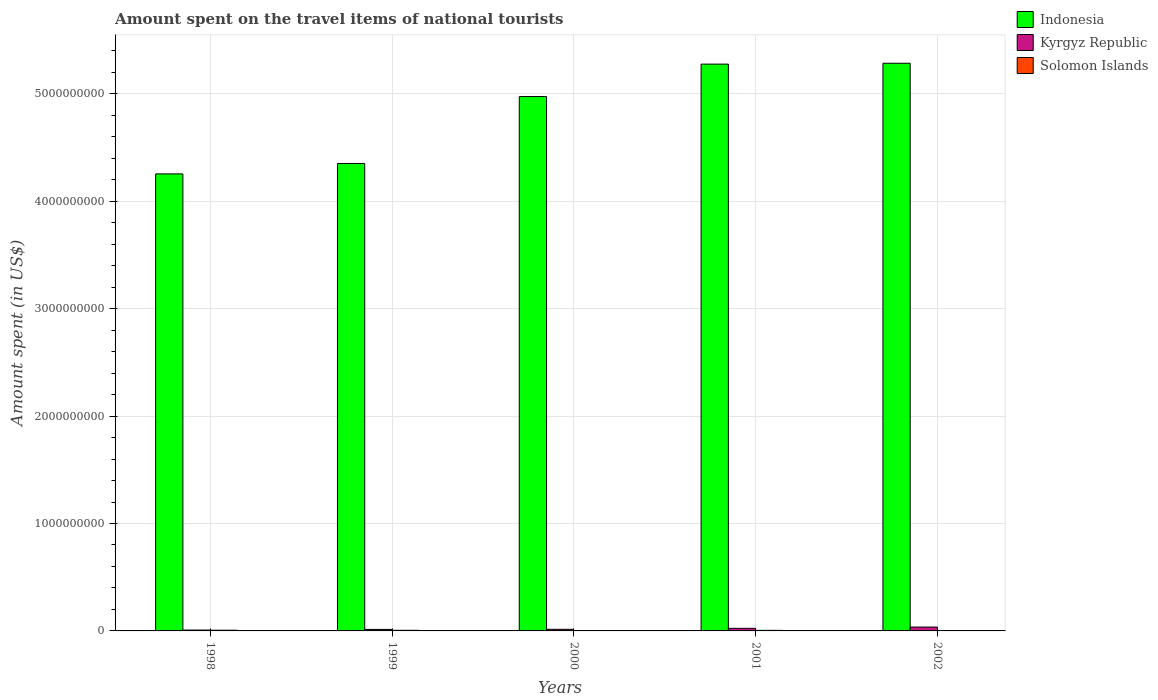How many groups of bars are there?
Your response must be concise. 5. Are the number of bars on each tick of the X-axis equal?
Ensure brevity in your answer.  Yes. How many bars are there on the 4th tick from the left?
Provide a succinct answer. 3. What is the label of the 1st group of bars from the left?
Your response must be concise. 1998. What is the amount spent on the travel items of national tourists in Solomon Islands in 2002?
Give a very brief answer. 7.00e+05. Across all years, what is the maximum amount spent on the travel items of national tourists in Indonesia?
Your answer should be very brief. 5.28e+09. Across all years, what is the minimum amount spent on the travel items of national tourists in Solomon Islands?
Give a very brief answer. 7.00e+05. In which year was the amount spent on the travel items of national tourists in Indonesia minimum?
Give a very brief answer. 1998. What is the total amount spent on the travel items of national tourists in Solomon Islands in the graph?
Offer a very short reply. 2.21e+07. What is the difference between the amount spent on the travel items of national tourists in Solomon Islands in 1999 and that in 2000?
Offer a very short reply. 1.80e+06. What is the difference between the amount spent on the travel items of national tourists in Kyrgyz Republic in 2000 and the amount spent on the travel items of national tourists in Indonesia in 1999?
Provide a succinct answer. -4.34e+09. What is the average amount spent on the travel items of national tourists in Solomon Islands per year?
Provide a succinct answer. 4.42e+06. In the year 2001, what is the difference between the amount spent on the travel items of national tourists in Indonesia and amount spent on the travel items of national tourists in Solomon Islands?
Give a very brief answer. 5.27e+09. What is the ratio of the amount spent on the travel items of national tourists in Solomon Islands in 1998 to that in 1999?
Make the answer very short. 1.16. Is the difference between the amount spent on the travel items of national tourists in Indonesia in 1998 and 1999 greater than the difference between the amount spent on the travel items of national tourists in Solomon Islands in 1998 and 1999?
Give a very brief answer. No. What is the difference between the highest and the lowest amount spent on the travel items of national tourists in Kyrgyz Republic?
Make the answer very short. 2.80e+07. In how many years, is the amount spent on the travel items of national tourists in Kyrgyz Republic greater than the average amount spent on the travel items of national tourists in Kyrgyz Republic taken over all years?
Your answer should be compact. 2. What does the 2nd bar from the left in 2000 represents?
Ensure brevity in your answer.  Kyrgyz Republic. What does the 2nd bar from the right in 2000 represents?
Make the answer very short. Kyrgyz Republic. Is it the case that in every year, the sum of the amount spent on the travel items of national tourists in Indonesia and amount spent on the travel items of national tourists in Solomon Islands is greater than the amount spent on the travel items of national tourists in Kyrgyz Republic?
Provide a succinct answer. Yes. How many bars are there?
Your response must be concise. 15. How many years are there in the graph?
Offer a very short reply. 5. Are the values on the major ticks of Y-axis written in scientific E-notation?
Your answer should be compact. No. Where does the legend appear in the graph?
Ensure brevity in your answer.  Top right. How are the legend labels stacked?
Provide a succinct answer. Vertical. What is the title of the graph?
Provide a short and direct response. Amount spent on the travel items of national tourists. What is the label or title of the Y-axis?
Your answer should be compact. Amount spent (in US$). What is the Amount spent (in US$) in Indonesia in 1998?
Give a very brief answer. 4.26e+09. What is the Amount spent (in US$) of Kyrgyz Republic in 1998?
Make the answer very short. 8.00e+06. What is the Amount spent (in US$) of Solomon Islands in 1998?
Keep it short and to the point. 6.60e+06. What is the Amount spent (in US$) of Indonesia in 1999?
Ensure brevity in your answer.  4.35e+09. What is the Amount spent (in US$) in Kyrgyz Republic in 1999?
Your answer should be compact. 1.40e+07. What is the Amount spent (in US$) in Solomon Islands in 1999?
Keep it short and to the point. 5.70e+06. What is the Amount spent (in US$) in Indonesia in 2000?
Provide a succinct answer. 4.98e+09. What is the Amount spent (in US$) in Kyrgyz Republic in 2000?
Offer a very short reply. 1.50e+07. What is the Amount spent (in US$) of Solomon Islands in 2000?
Offer a very short reply. 3.90e+06. What is the Amount spent (in US$) in Indonesia in 2001?
Ensure brevity in your answer.  5.28e+09. What is the Amount spent (in US$) in Kyrgyz Republic in 2001?
Offer a terse response. 2.40e+07. What is the Amount spent (in US$) of Solomon Islands in 2001?
Your answer should be very brief. 5.20e+06. What is the Amount spent (in US$) in Indonesia in 2002?
Offer a terse response. 5.28e+09. What is the Amount spent (in US$) in Kyrgyz Republic in 2002?
Give a very brief answer. 3.60e+07. What is the Amount spent (in US$) in Solomon Islands in 2002?
Offer a terse response. 7.00e+05. Across all years, what is the maximum Amount spent (in US$) in Indonesia?
Ensure brevity in your answer.  5.28e+09. Across all years, what is the maximum Amount spent (in US$) of Kyrgyz Republic?
Offer a very short reply. 3.60e+07. Across all years, what is the maximum Amount spent (in US$) in Solomon Islands?
Keep it short and to the point. 6.60e+06. Across all years, what is the minimum Amount spent (in US$) of Indonesia?
Give a very brief answer. 4.26e+09. Across all years, what is the minimum Amount spent (in US$) of Kyrgyz Republic?
Keep it short and to the point. 8.00e+06. Across all years, what is the minimum Amount spent (in US$) of Solomon Islands?
Provide a short and direct response. 7.00e+05. What is the total Amount spent (in US$) in Indonesia in the graph?
Ensure brevity in your answer.  2.41e+1. What is the total Amount spent (in US$) in Kyrgyz Republic in the graph?
Your response must be concise. 9.70e+07. What is the total Amount spent (in US$) in Solomon Islands in the graph?
Provide a short and direct response. 2.21e+07. What is the difference between the Amount spent (in US$) of Indonesia in 1998 and that in 1999?
Offer a terse response. -9.70e+07. What is the difference between the Amount spent (in US$) of Kyrgyz Republic in 1998 and that in 1999?
Ensure brevity in your answer.  -6.00e+06. What is the difference between the Amount spent (in US$) in Solomon Islands in 1998 and that in 1999?
Make the answer very short. 9.00e+05. What is the difference between the Amount spent (in US$) in Indonesia in 1998 and that in 2000?
Provide a short and direct response. -7.20e+08. What is the difference between the Amount spent (in US$) in Kyrgyz Republic in 1998 and that in 2000?
Ensure brevity in your answer.  -7.00e+06. What is the difference between the Amount spent (in US$) of Solomon Islands in 1998 and that in 2000?
Your answer should be compact. 2.70e+06. What is the difference between the Amount spent (in US$) of Indonesia in 1998 and that in 2001?
Make the answer very short. -1.02e+09. What is the difference between the Amount spent (in US$) of Kyrgyz Republic in 1998 and that in 2001?
Keep it short and to the point. -1.60e+07. What is the difference between the Amount spent (in US$) in Solomon Islands in 1998 and that in 2001?
Offer a very short reply. 1.40e+06. What is the difference between the Amount spent (in US$) of Indonesia in 1998 and that in 2002?
Provide a short and direct response. -1.03e+09. What is the difference between the Amount spent (in US$) of Kyrgyz Republic in 1998 and that in 2002?
Your answer should be very brief. -2.80e+07. What is the difference between the Amount spent (in US$) in Solomon Islands in 1998 and that in 2002?
Ensure brevity in your answer.  5.90e+06. What is the difference between the Amount spent (in US$) of Indonesia in 1999 and that in 2000?
Offer a terse response. -6.23e+08. What is the difference between the Amount spent (in US$) of Kyrgyz Republic in 1999 and that in 2000?
Ensure brevity in your answer.  -1.00e+06. What is the difference between the Amount spent (in US$) in Solomon Islands in 1999 and that in 2000?
Offer a terse response. 1.80e+06. What is the difference between the Amount spent (in US$) of Indonesia in 1999 and that in 2001?
Offer a very short reply. -9.25e+08. What is the difference between the Amount spent (in US$) in Kyrgyz Republic in 1999 and that in 2001?
Ensure brevity in your answer.  -1.00e+07. What is the difference between the Amount spent (in US$) of Solomon Islands in 1999 and that in 2001?
Your answer should be compact. 5.00e+05. What is the difference between the Amount spent (in US$) of Indonesia in 1999 and that in 2002?
Provide a short and direct response. -9.33e+08. What is the difference between the Amount spent (in US$) of Kyrgyz Republic in 1999 and that in 2002?
Your response must be concise. -2.20e+07. What is the difference between the Amount spent (in US$) in Solomon Islands in 1999 and that in 2002?
Make the answer very short. 5.00e+06. What is the difference between the Amount spent (in US$) of Indonesia in 2000 and that in 2001?
Give a very brief answer. -3.02e+08. What is the difference between the Amount spent (in US$) of Kyrgyz Republic in 2000 and that in 2001?
Give a very brief answer. -9.00e+06. What is the difference between the Amount spent (in US$) in Solomon Islands in 2000 and that in 2001?
Make the answer very short. -1.30e+06. What is the difference between the Amount spent (in US$) in Indonesia in 2000 and that in 2002?
Provide a succinct answer. -3.10e+08. What is the difference between the Amount spent (in US$) of Kyrgyz Republic in 2000 and that in 2002?
Your answer should be compact. -2.10e+07. What is the difference between the Amount spent (in US$) in Solomon Islands in 2000 and that in 2002?
Your answer should be compact. 3.20e+06. What is the difference between the Amount spent (in US$) of Indonesia in 2001 and that in 2002?
Your answer should be very brief. -8.00e+06. What is the difference between the Amount spent (in US$) in Kyrgyz Republic in 2001 and that in 2002?
Give a very brief answer. -1.20e+07. What is the difference between the Amount spent (in US$) in Solomon Islands in 2001 and that in 2002?
Your answer should be very brief. 4.50e+06. What is the difference between the Amount spent (in US$) of Indonesia in 1998 and the Amount spent (in US$) of Kyrgyz Republic in 1999?
Make the answer very short. 4.24e+09. What is the difference between the Amount spent (in US$) of Indonesia in 1998 and the Amount spent (in US$) of Solomon Islands in 1999?
Provide a succinct answer. 4.25e+09. What is the difference between the Amount spent (in US$) in Kyrgyz Republic in 1998 and the Amount spent (in US$) in Solomon Islands in 1999?
Your response must be concise. 2.30e+06. What is the difference between the Amount spent (in US$) in Indonesia in 1998 and the Amount spent (in US$) in Kyrgyz Republic in 2000?
Provide a short and direct response. 4.24e+09. What is the difference between the Amount spent (in US$) of Indonesia in 1998 and the Amount spent (in US$) of Solomon Islands in 2000?
Make the answer very short. 4.25e+09. What is the difference between the Amount spent (in US$) in Kyrgyz Republic in 1998 and the Amount spent (in US$) in Solomon Islands in 2000?
Keep it short and to the point. 4.10e+06. What is the difference between the Amount spent (in US$) of Indonesia in 1998 and the Amount spent (in US$) of Kyrgyz Republic in 2001?
Provide a short and direct response. 4.23e+09. What is the difference between the Amount spent (in US$) of Indonesia in 1998 and the Amount spent (in US$) of Solomon Islands in 2001?
Provide a short and direct response. 4.25e+09. What is the difference between the Amount spent (in US$) in Kyrgyz Republic in 1998 and the Amount spent (in US$) in Solomon Islands in 2001?
Provide a short and direct response. 2.80e+06. What is the difference between the Amount spent (in US$) in Indonesia in 1998 and the Amount spent (in US$) in Kyrgyz Republic in 2002?
Offer a terse response. 4.22e+09. What is the difference between the Amount spent (in US$) of Indonesia in 1998 and the Amount spent (in US$) of Solomon Islands in 2002?
Provide a short and direct response. 4.25e+09. What is the difference between the Amount spent (in US$) of Kyrgyz Republic in 1998 and the Amount spent (in US$) of Solomon Islands in 2002?
Ensure brevity in your answer.  7.30e+06. What is the difference between the Amount spent (in US$) of Indonesia in 1999 and the Amount spent (in US$) of Kyrgyz Republic in 2000?
Give a very brief answer. 4.34e+09. What is the difference between the Amount spent (in US$) in Indonesia in 1999 and the Amount spent (in US$) in Solomon Islands in 2000?
Offer a very short reply. 4.35e+09. What is the difference between the Amount spent (in US$) of Kyrgyz Republic in 1999 and the Amount spent (in US$) of Solomon Islands in 2000?
Ensure brevity in your answer.  1.01e+07. What is the difference between the Amount spent (in US$) in Indonesia in 1999 and the Amount spent (in US$) in Kyrgyz Republic in 2001?
Provide a succinct answer. 4.33e+09. What is the difference between the Amount spent (in US$) of Indonesia in 1999 and the Amount spent (in US$) of Solomon Islands in 2001?
Ensure brevity in your answer.  4.35e+09. What is the difference between the Amount spent (in US$) in Kyrgyz Republic in 1999 and the Amount spent (in US$) in Solomon Islands in 2001?
Keep it short and to the point. 8.80e+06. What is the difference between the Amount spent (in US$) in Indonesia in 1999 and the Amount spent (in US$) in Kyrgyz Republic in 2002?
Your answer should be very brief. 4.32e+09. What is the difference between the Amount spent (in US$) in Indonesia in 1999 and the Amount spent (in US$) in Solomon Islands in 2002?
Ensure brevity in your answer.  4.35e+09. What is the difference between the Amount spent (in US$) of Kyrgyz Republic in 1999 and the Amount spent (in US$) of Solomon Islands in 2002?
Give a very brief answer. 1.33e+07. What is the difference between the Amount spent (in US$) in Indonesia in 2000 and the Amount spent (in US$) in Kyrgyz Republic in 2001?
Offer a terse response. 4.95e+09. What is the difference between the Amount spent (in US$) of Indonesia in 2000 and the Amount spent (in US$) of Solomon Islands in 2001?
Your answer should be compact. 4.97e+09. What is the difference between the Amount spent (in US$) of Kyrgyz Republic in 2000 and the Amount spent (in US$) of Solomon Islands in 2001?
Your answer should be compact. 9.80e+06. What is the difference between the Amount spent (in US$) of Indonesia in 2000 and the Amount spent (in US$) of Kyrgyz Republic in 2002?
Provide a short and direct response. 4.94e+09. What is the difference between the Amount spent (in US$) of Indonesia in 2000 and the Amount spent (in US$) of Solomon Islands in 2002?
Offer a terse response. 4.97e+09. What is the difference between the Amount spent (in US$) of Kyrgyz Republic in 2000 and the Amount spent (in US$) of Solomon Islands in 2002?
Keep it short and to the point. 1.43e+07. What is the difference between the Amount spent (in US$) of Indonesia in 2001 and the Amount spent (in US$) of Kyrgyz Republic in 2002?
Make the answer very short. 5.24e+09. What is the difference between the Amount spent (in US$) of Indonesia in 2001 and the Amount spent (in US$) of Solomon Islands in 2002?
Make the answer very short. 5.28e+09. What is the difference between the Amount spent (in US$) of Kyrgyz Republic in 2001 and the Amount spent (in US$) of Solomon Islands in 2002?
Your answer should be compact. 2.33e+07. What is the average Amount spent (in US$) of Indonesia per year?
Your answer should be compact. 4.83e+09. What is the average Amount spent (in US$) of Kyrgyz Republic per year?
Make the answer very short. 1.94e+07. What is the average Amount spent (in US$) in Solomon Islands per year?
Provide a short and direct response. 4.42e+06. In the year 1998, what is the difference between the Amount spent (in US$) of Indonesia and Amount spent (in US$) of Kyrgyz Republic?
Keep it short and to the point. 4.25e+09. In the year 1998, what is the difference between the Amount spent (in US$) in Indonesia and Amount spent (in US$) in Solomon Islands?
Your response must be concise. 4.25e+09. In the year 1998, what is the difference between the Amount spent (in US$) in Kyrgyz Republic and Amount spent (in US$) in Solomon Islands?
Your response must be concise. 1.40e+06. In the year 1999, what is the difference between the Amount spent (in US$) of Indonesia and Amount spent (in US$) of Kyrgyz Republic?
Give a very brief answer. 4.34e+09. In the year 1999, what is the difference between the Amount spent (in US$) in Indonesia and Amount spent (in US$) in Solomon Islands?
Your answer should be compact. 4.35e+09. In the year 1999, what is the difference between the Amount spent (in US$) of Kyrgyz Republic and Amount spent (in US$) of Solomon Islands?
Make the answer very short. 8.30e+06. In the year 2000, what is the difference between the Amount spent (in US$) in Indonesia and Amount spent (in US$) in Kyrgyz Republic?
Provide a succinct answer. 4.96e+09. In the year 2000, what is the difference between the Amount spent (in US$) of Indonesia and Amount spent (in US$) of Solomon Islands?
Offer a terse response. 4.97e+09. In the year 2000, what is the difference between the Amount spent (in US$) in Kyrgyz Republic and Amount spent (in US$) in Solomon Islands?
Offer a terse response. 1.11e+07. In the year 2001, what is the difference between the Amount spent (in US$) in Indonesia and Amount spent (in US$) in Kyrgyz Republic?
Your answer should be compact. 5.25e+09. In the year 2001, what is the difference between the Amount spent (in US$) of Indonesia and Amount spent (in US$) of Solomon Islands?
Give a very brief answer. 5.27e+09. In the year 2001, what is the difference between the Amount spent (in US$) of Kyrgyz Republic and Amount spent (in US$) of Solomon Islands?
Your answer should be compact. 1.88e+07. In the year 2002, what is the difference between the Amount spent (in US$) in Indonesia and Amount spent (in US$) in Kyrgyz Republic?
Keep it short and to the point. 5.25e+09. In the year 2002, what is the difference between the Amount spent (in US$) in Indonesia and Amount spent (in US$) in Solomon Islands?
Offer a very short reply. 5.28e+09. In the year 2002, what is the difference between the Amount spent (in US$) of Kyrgyz Republic and Amount spent (in US$) of Solomon Islands?
Offer a very short reply. 3.53e+07. What is the ratio of the Amount spent (in US$) in Indonesia in 1998 to that in 1999?
Ensure brevity in your answer.  0.98. What is the ratio of the Amount spent (in US$) in Solomon Islands in 1998 to that in 1999?
Your answer should be compact. 1.16. What is the ratio of the Amount spent (in US$) of Indonesia in 1998 to that in 2000?
Ensure brevity in your answer.  0.86. What is the ratio of the Amount spent (in US$) in Kyrgyz Republic in 1998 to that in 2000?
Provide a succinct answer. 0.53. What is the ratio of the Amount spent (in US$) of Solomon Islands in 1998 to that in 2000?
Give a very brief answer. 1.69. What is the ratio of the Amount spent (in US$) in Indonesia in 1998 to that in 2001?
Offer a very short reply. 0.81. What is the ratio of the Amount spent (in US$) in Kyrgyz Republic in 1998 to that in 2001?
Your response must be concise. 0.33. What is the ratio of the Amount spent (in US$) in Solomon Islands in 1998 to that in 2001?
Make the answer very short. 1.27. What is the ratio of the Amount spent (in US$) in Indonesia in 1998 to that in 2002?
Your answer should be compact. 0.81. What is the ratio of the Amount spent (in US$) in Kyrgyz Republic in 1998 to that in 2002?
Your response must be concise. 0.22. What is the ratio of the Amount spent (in US$) in Solomon Islands in 1998 to that in 2002?
Provide a short and direct response. 9.43. What is the ratio of the Amount spent (in US$) in Indonesia in 1999 to that in 2000?
Your answer should be compact. 0.87. What is the ratio of the Amount spent (in US$) of Kyrgyz Republic in 1999 to that in 2000?
Ensure brevity in your answer.  0.93. What is the ratio of the Amount spent (in US$) in Solomon Islands in 1999 to that in 2000?
Your answer should be compact. 1.46. What is the ratio of the Amount spent (in US$) in Indonesia in 1999 to that in 2001?
Ensure brevity in your answer.  0.82. What is the ratio of the Amount spent (in US$) of Kyrgyz Republic in 1999 to that in 2001?
Offer a terse response. 0.58. What is the ratio of the Amount spent (in US$) of Solomon Islands in 1999 to that in 2001?
Your response must be concise. 1.1. What is the ratio of the Amount spent (in US$) of Indonesia in 1999 to that in 2002?
Keep it short and to the point. 0.82. What is the ratio of the Amount spent (in US$) in Kyrgyz Republic in 1999 to that in 2002?
Give a very brief answer. 0.39. What is the ratio of the Amount spent (in US$) in Solomon Islands in 1999 to that in 2002?
Offer a very short reply. 8.14. What is the ratio of the Amount spent (in US$) in Indonesia in 2000 to that in 2001?
Your response must be concise. 0.94. What is the ratio of the Amount spent (in US$) of Indonesia in 2000 to that in 2002?
Your answer should be very brief. 0.94. What is the ratio of the Amount spent (in US$) in Kyrgyz Republic in 2000 to that in 2002?
Your response must be concise. 0.42. What is the ratio of the Amount spent (in US$) of Solomon Islands in 2000 to that in 2002?
Ensure brevity in your answer.  5.57. What is the ratio of the Amount spent (in US$) in Indonesia in 2001 to that in 2002?
Keep it short and to the point. 1. What is the ratio of the Amount spent (in US$) of Solomon Islands in 2001 to that in 2002?
Your answer should be very brief. 7.43. What is the difference between the highest and the second highest Amount spent (in US$) in Indonesia?
Provide a short and direct response. 8.00e+06. What is the difference between the highest and the second highest Amount spent (in US$) in Kyrgyz Republic?
Offer a very short reply. 1.20e+07. What is the difference between the highest and the lowest Amount spent (in US$) of Indonesia?
Provide a short and direct response. 1.03e+09. What is the difference between the highest and the lowest Amount spent (in US$) of Kyrgyz Republic?
Make the answer very short. 2.80e+07. What is the difference between the highest and the lowest Amount spent (in US$) of Solomon Islands?
Give a very brief answer. 5.90e+06. 